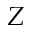Convert formula to latex. <formula><loc_0><loc_0><loc_500><loc_500>Z</formula> 